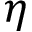<formula> <loc_0><loc_0><loc_500><loc_500>\eta</formula> 